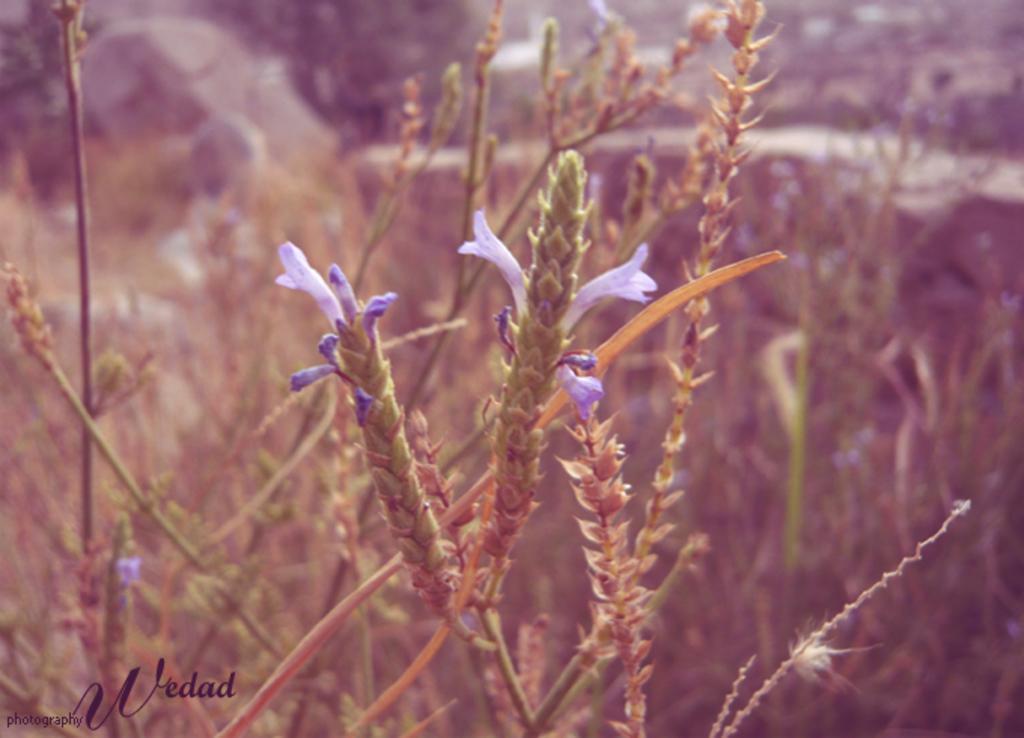Please provide a concise description of this image. In this image I can see few purple color flowers and plants. Background is blurred. 